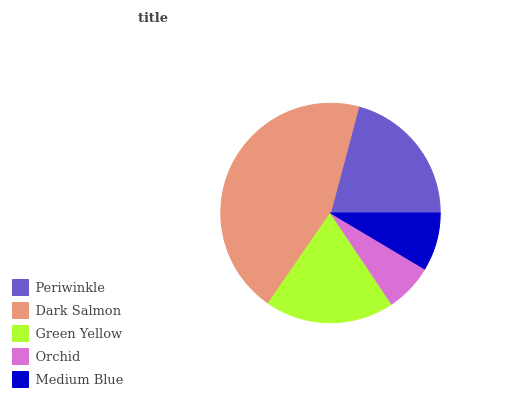Is Orchid the minimum?
Answer yes or no. Yes. Is Dark Salmon the maximum?
Answer yes or no. Yes. Is Green Yellow the minimum?
Answer yes or no. No. Is Green Yellow the maximum?
Answer yes or no. No. Is Dark Salmon greater than Green Yellow?
Answer yes or no. Yes. Is Green Yellow less than Dark Salmon?
Answer yes or no. Yes. Is Green Yellow greater than Dark Salmon?
Answer yes or no. No. Is Dark Salmon less than Green Yellow?
Answer yes or no. No. Is Green Yellow the high median?
Answer yes or no. Yes. Is Green Yellow the low median?
Answer yes or no. Yes. Is Periwinkle the high median?
Answer yes or no. No. Is Orchid the low median?
Answer yes or no. No. 